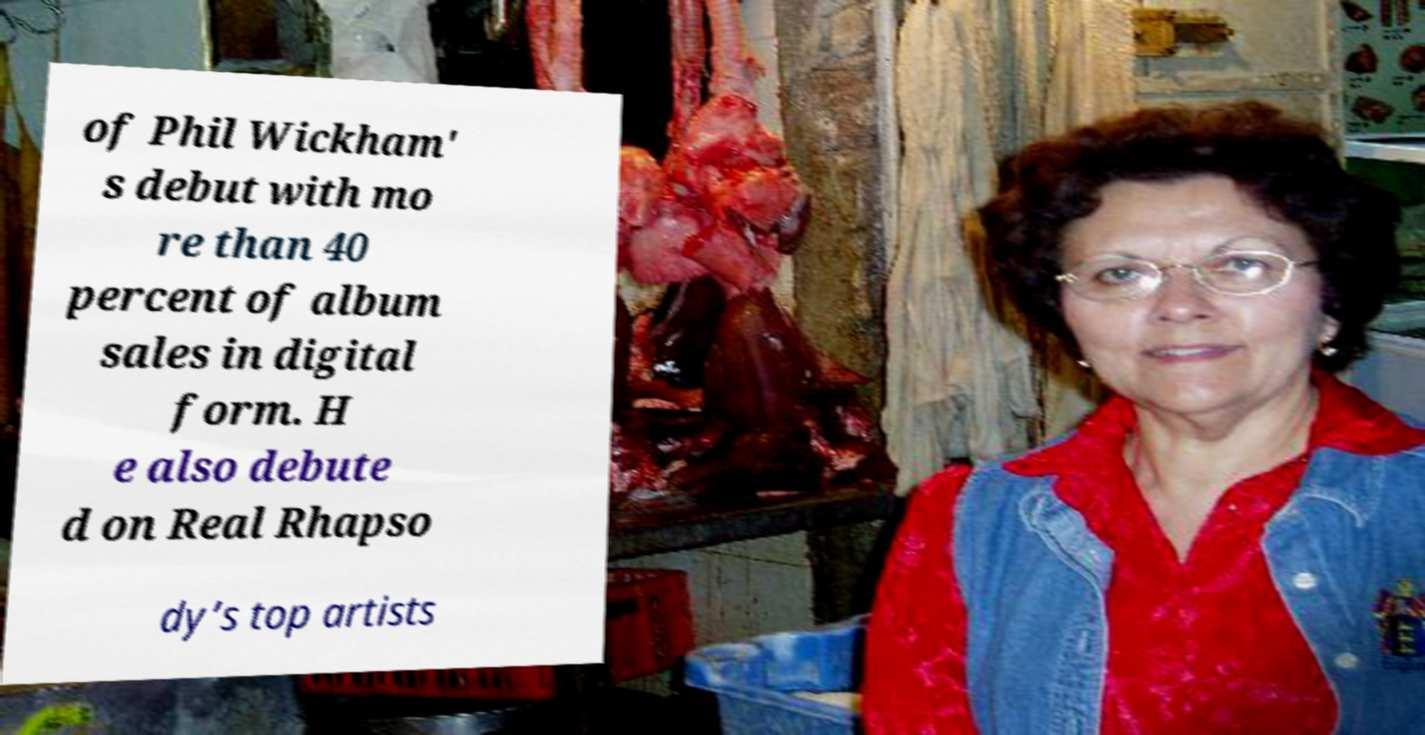What messages or text are displayed in this image? I need them in a readable, typed format. of Phil Wickham' s debut with mo re than 40 percent of album sales in digital form. H e also debute d on Real Rhapso dy’s top artists 